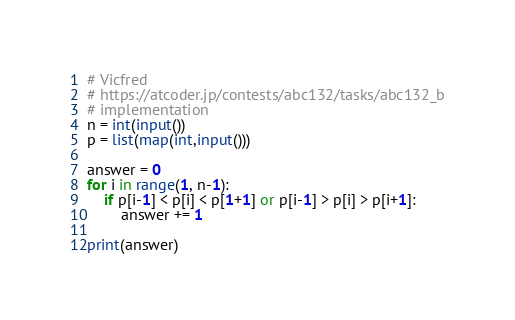Convert code to text. <code><loc_0><loc_0><loc_500><loc_500><_Python_># Vicfred
# https://atcoder.jp/contests/abc132/tasks/abc132_b
# implementation
n = int(input())
p = list(map(int,input()))

answer = 0
for i in range(1, n-1):
    if p[i-1] < p[i] < p[1+1] or p[i-1] > p[i] > p[i+1]:
        answer += 1

print(answer)

</code> 